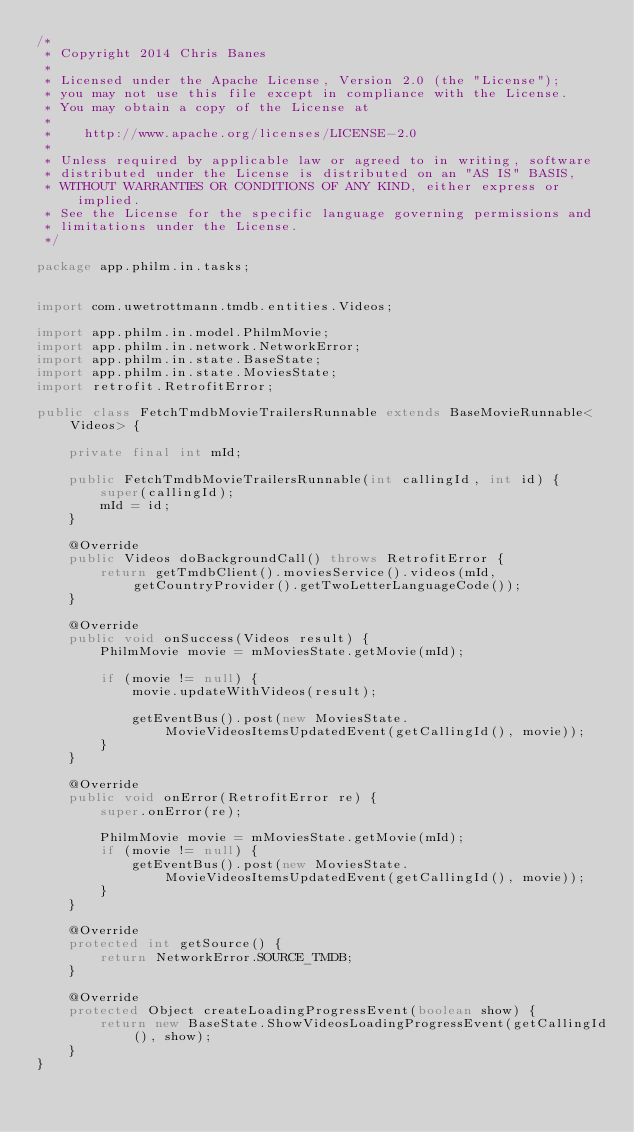Convert code to text. <code><loc_0><loc_0><loc_500><loc_500><_Java_>/*
 * Copyright 2014 Chris Banes
 *
 * Licensed under the Apache License, Version 2.0 (the "License");
 * you may not use this file except in compliance with the License.
 * You may obtain a copy of the License at
 *
 *    http://www.apache.org/licenses/LICENSE-2.0
 *
 * Unless required by applicable law or agreed to in writing, software
 * distributed under the License is distributed on an "AS IS" BASIS,
 * WITHOUT WARRANTIES OR CONDITIONS OF ANY KIND, either express or implied.
 * See the License for the specific language governing permissions and
 * limitations under the License.
 */

package app.philm.in.tasks;


import com.uwetrottmann.tmdb.entities.Videos;

import app.philm.in.model.PhilmMovie;
import app.philm.in.network.NetworkError;
import app.philm.in.state.BaseState;
import app.philm.in.state.MoviesState;
import retrofit.RetrofitError;

public class FetchTmdbMovieTrailersRunnable extends BaseMovieRunnable<Videos> {

    private final int mId;

    public FetchTmdbMovieTrailersRunnable(int callingId, int id) {
        super(callingId);
        mId = id;
    }

    @Override
    public Videos doBackgroundCall() throws RetrofitError {
        return getTmdbClient().moviesService().videos(mId, getCountryProvider().getTwoLetterLanguageCode());
    }

    @Override
    public void onSuccess(Videos result) {
        PhilmMovie movie = mMoviesState.getMovie(mId);

        if (movie != null) {
            movie.updateWithVideos(result);

            getEventBus().post(new MoviesState.MovieVideosItemsUpdatedEvent(getCallingId(), movie));
        }
    }

    @Override
    public void onError(RetrofitError re) {
        super.onError(re);

        PhilmMovie movie = mMoviesState.getMovie(mId);
        if (movie != null) {
            getEventBus().post(new MoviesState.MovieVideosItemsUpdatedEvent(getCallingId(), movie));
        }
    }

    @Override
    protected int getSource() {
        return NetworkError.SOURCE_TMDB;
    }

    @Override
    protected Object createLoadingProgressEvent(boolean show) {
        return new BaseState.ShowVideosLoadingProgressEvent(getCallingId(), show);
    }
}</code> 